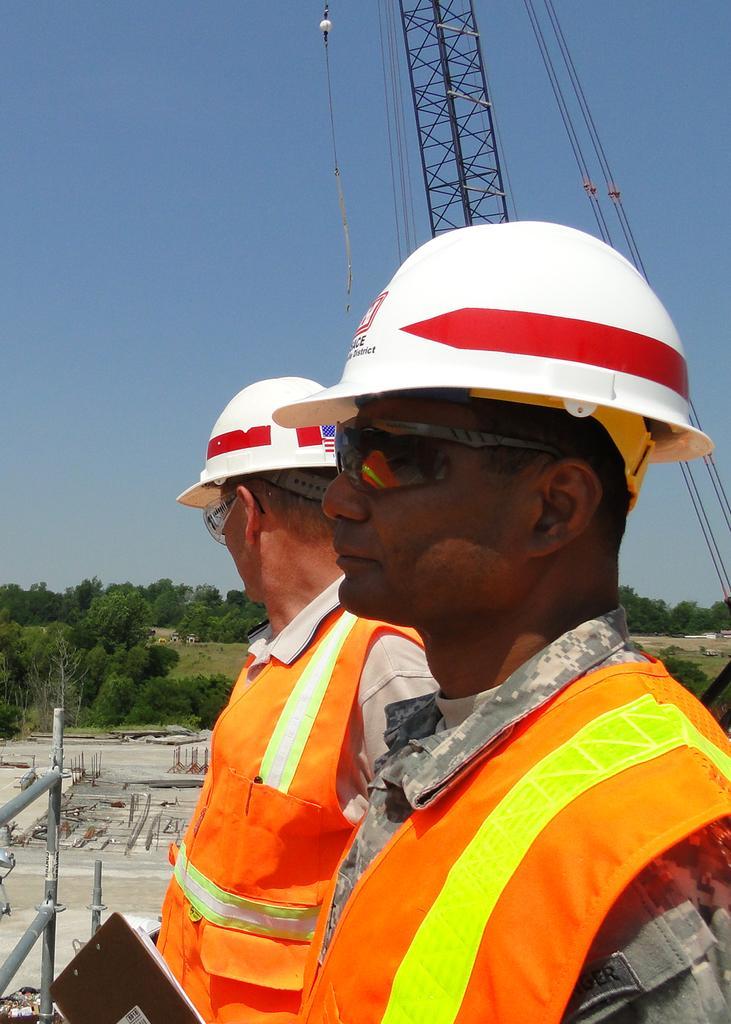Please provide a concise description of this image. In this picture we can observe two men wearing orange color coats and white color helmets. They are wearing spectacles. We can observe a mobile crane hire. In the background there is a construction site and some trees. We can observe a sky here. 